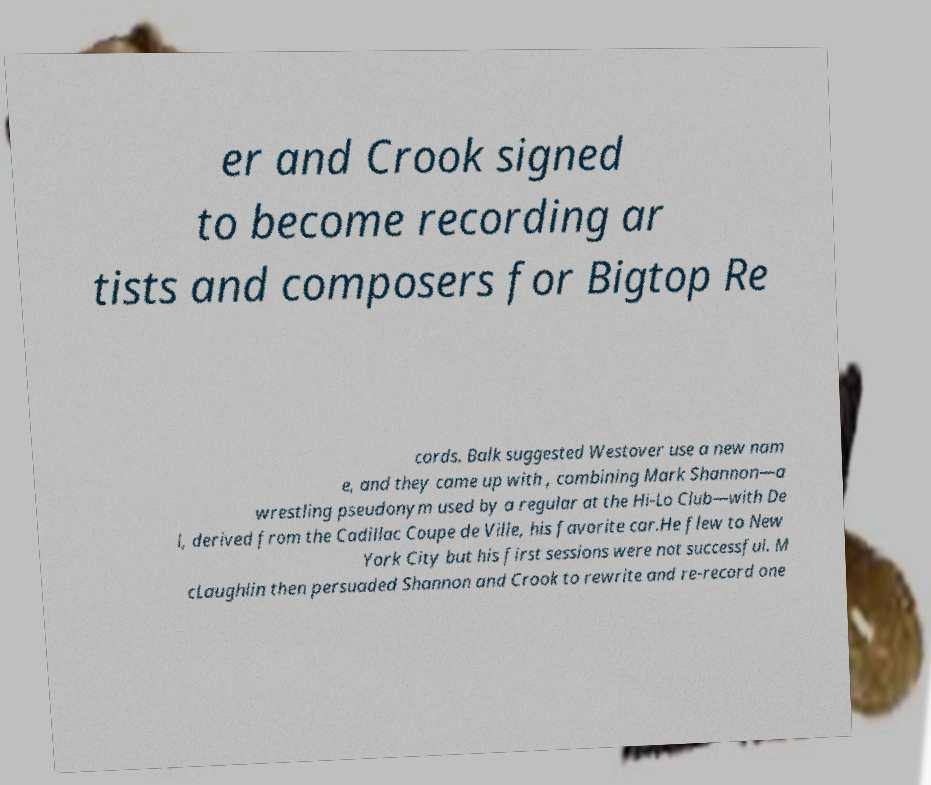Can you accurately transcribe the text from the provided image for me? er and Crook signed to become recording ar tists and composers for Bigtop Re cords. Balk suggested Westover use a new nam e, and they came up with , combining Mark Shannon—a wrestling pseudonym used by a regular at the Hi-Lo Club—with De l, derived from the Cadillac Coupe de Ville, his favorite car.He flew to New York City but his first sessions were not successful. M cLaughlin then persuaded Shannon and Crook to rewrite and re-record one 